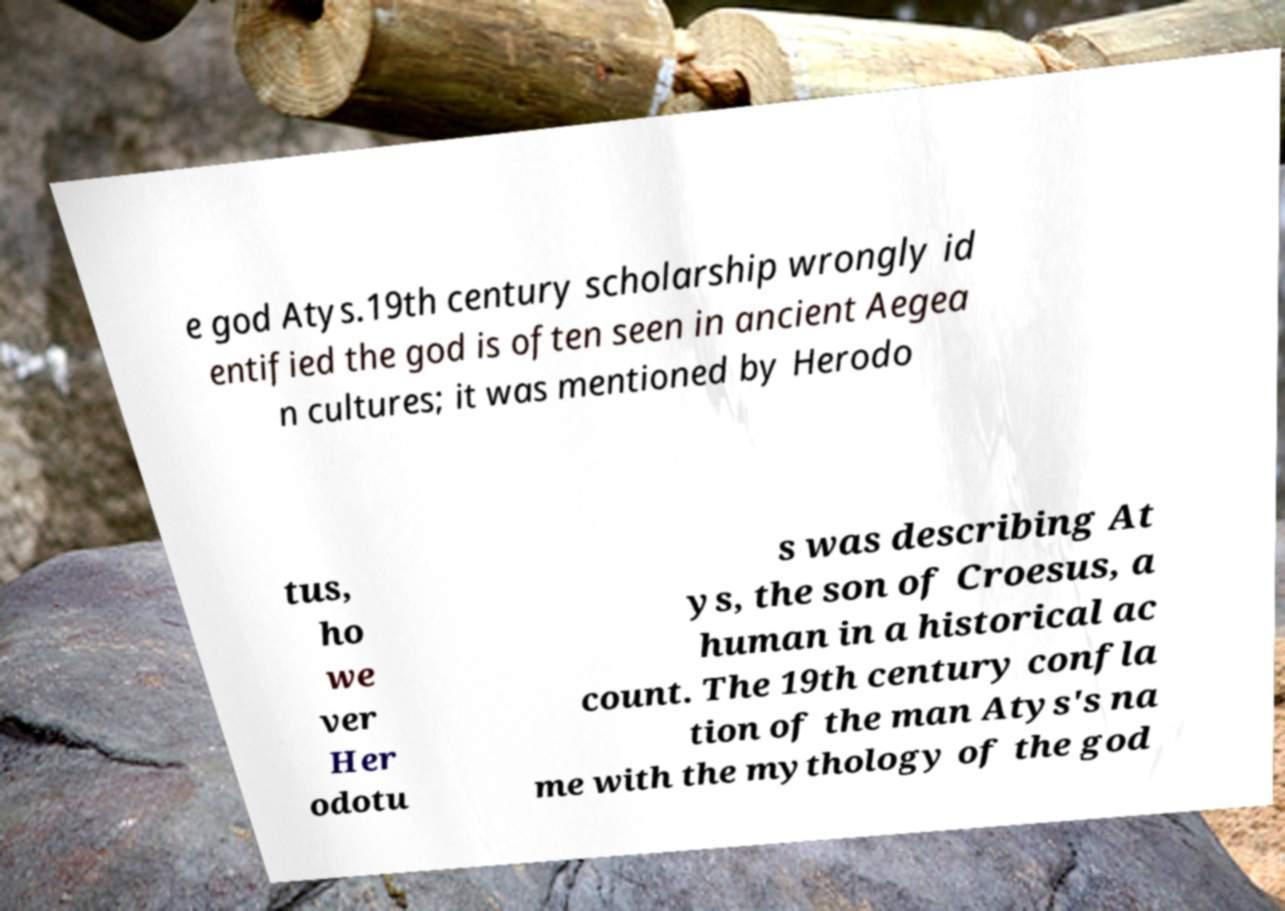Could you extract and type out the text from this image? e god Atys.19th century scholarship wrongly id entified the god is often seen in ancient Aegea n cultures; it was mentioned by Herodo tus, ho we ver Her odotu s was describing At ys, the son of Croesus, a human in a historical ac count. The 19th century confla tion of the man Atys's na me with the mythology of the god 